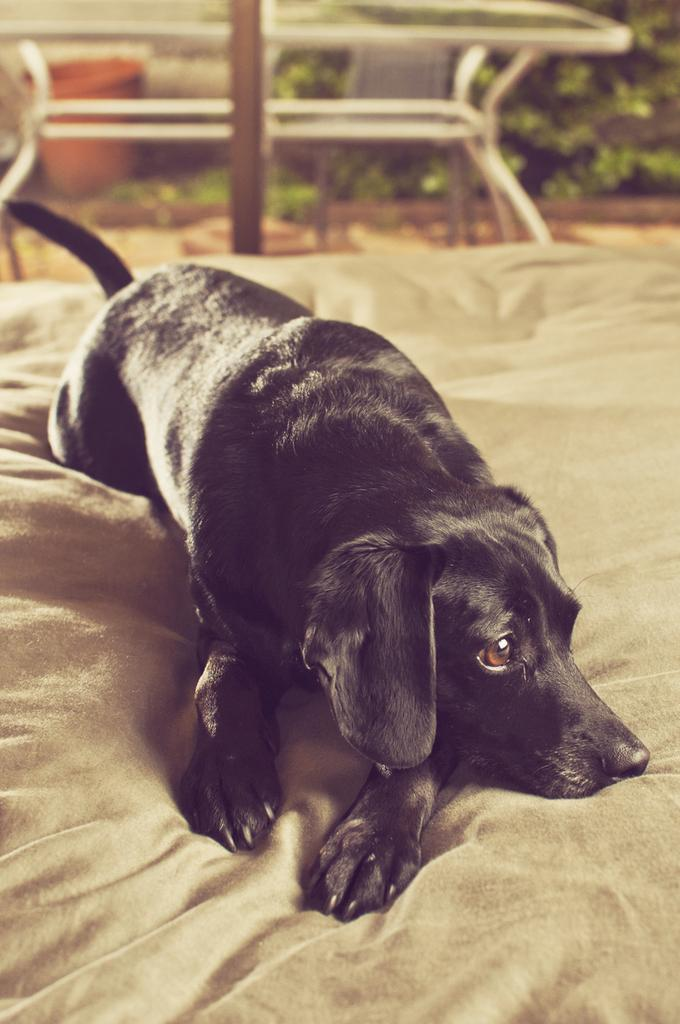What type of animal is in the image? There is a black dog in the image. What is the dog doing in the image? The dog is laying on a cloth. What can be seen in the image besides the dog? There are plants visible in the image. What is the condition of the objects in the background of the image? There are blurred objects in the background of the image. What type of scarf is the dog wearing in the image? There is no scarf present in the image; the dog is laying on a cloth. What news event is being discussed in the image? There is no news event or discussion present in the image; it features a black dog laying on a cloth with plants and blurred background objects. 